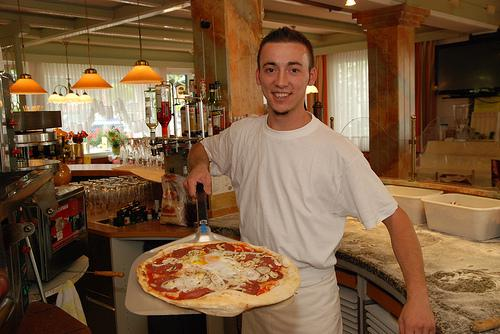Question: who is in the picture?
Choices:
A. A player is in the photo.
B. A cook is in the picture.
C. A waiter is in the picture.
D. A janitor is shown in the photograph.
Answer with the letter. Answer: B Question: what color is the cooks shirt?
Choices:
A. Blue.
B. The shirt is white.
C. Grey.
D. Tan.
Answer with the letter. Answer: B Question: what color is the cook?
Choices:
A. Pink.
B. Tan.
C. The cook is white.
D. Brown.
Answer with the letter. Answer: C Question: how does the cook look?
Choices:
A. The cook looks super angry.
B. The cook looks very sad.
C. The cook looks surprised.
D. The cook looks very happy.
Answer with the letter. Answer: D Question: where is the cook?
Choices:
A. The cook is behind the counter.
B. The cook is in the kitchen.
C. The cook us going to the bathroom.
D. The cook is in a restaurant.
Answer with the letter. Answer: D 